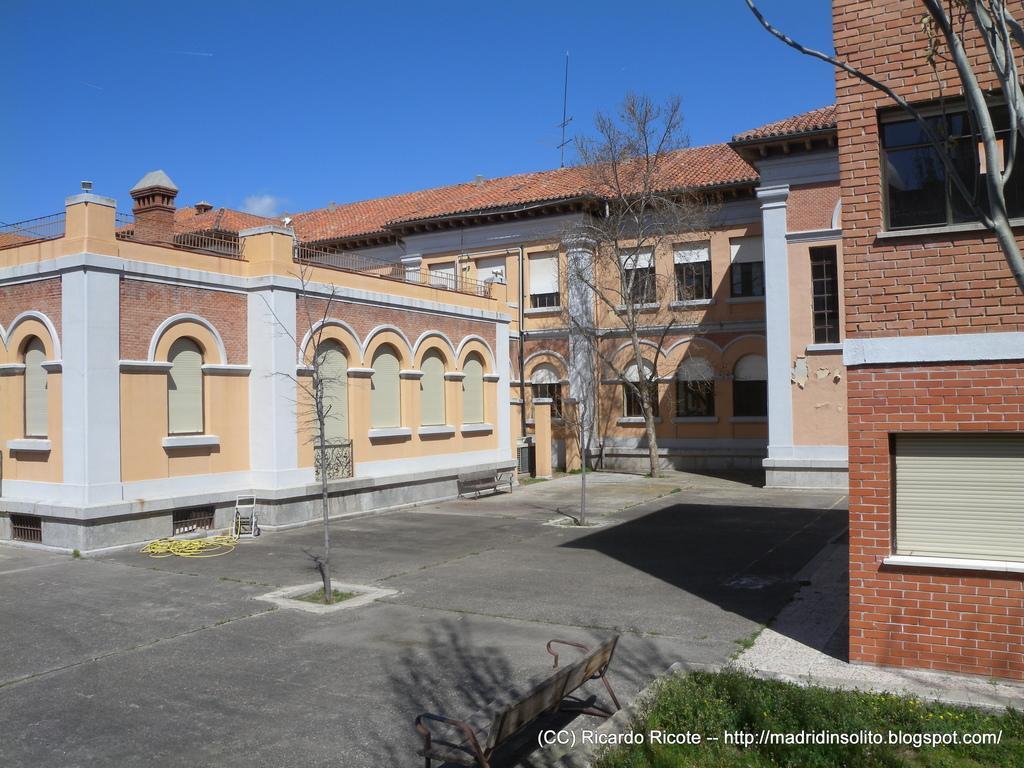Please provide a concise description of this image. In this picture I can see the path on which there are few tree and I see 2 benches. On the right side of this image I see the grass, a tree and the watermark. In the background I see the buildings and the sky. 